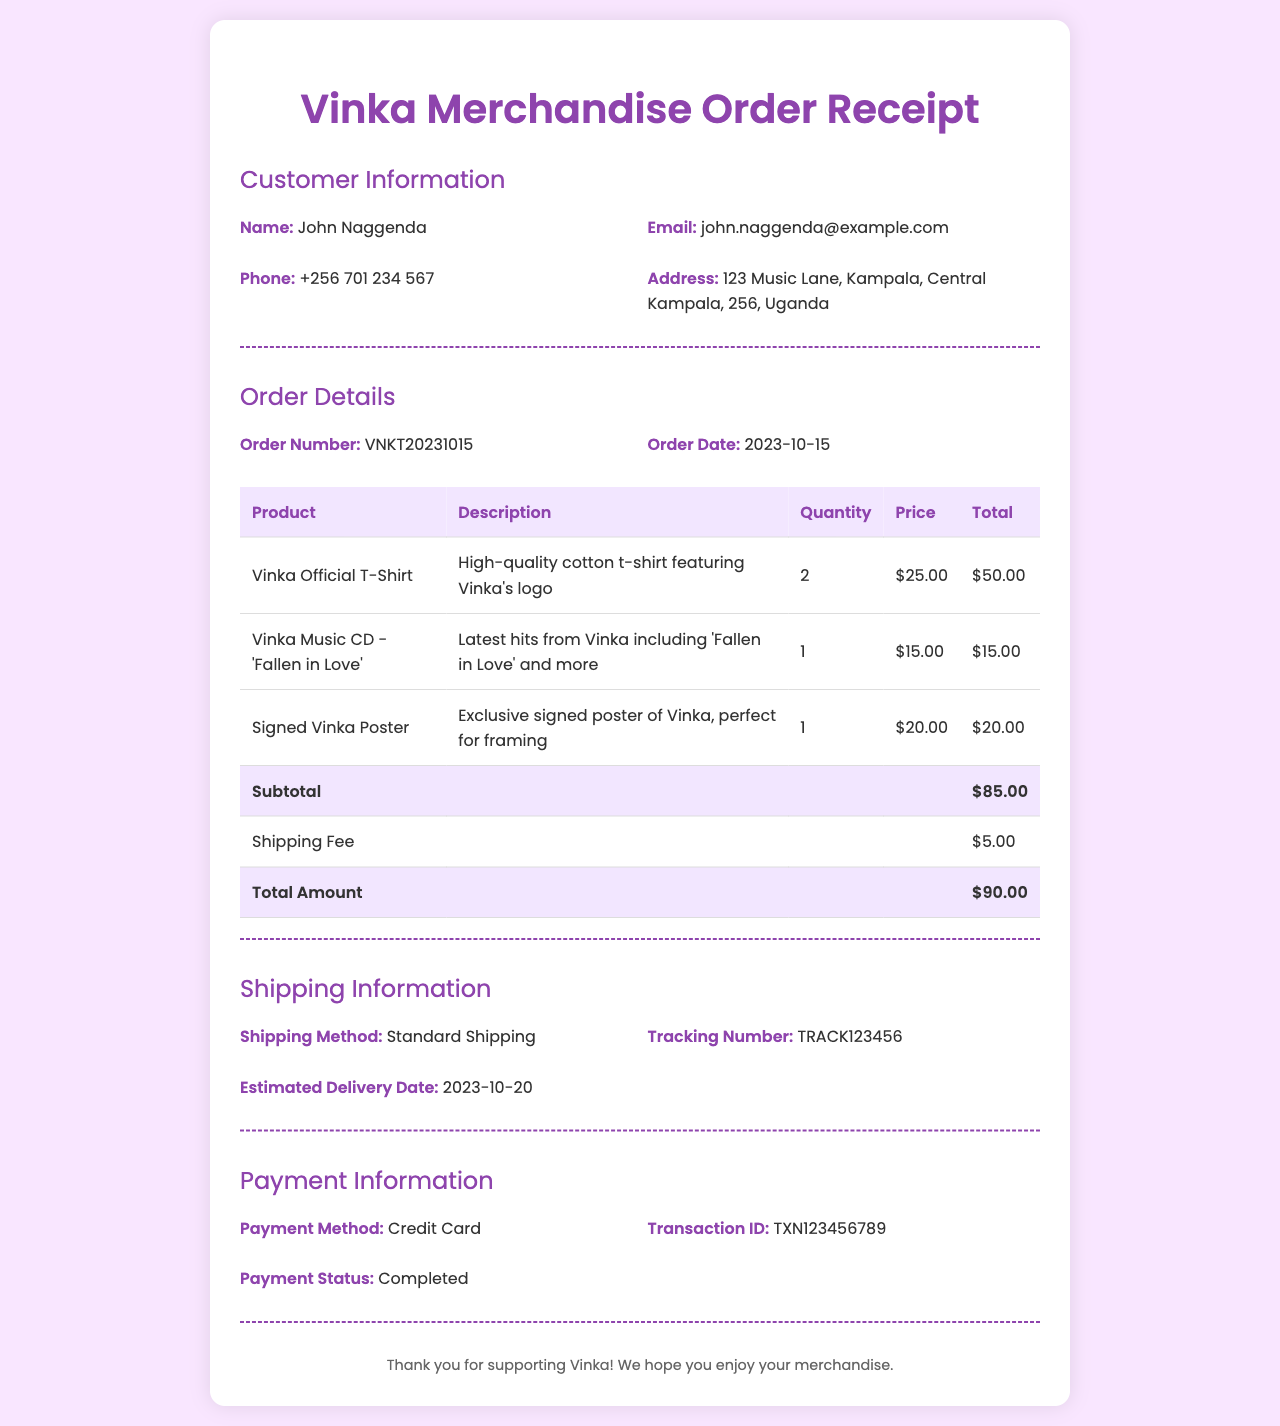What is the order number? The order number is found in the order details section of the document, specifically listed as VNKT20231015.
Answer: VNKT20231015 What is the total amount paid? The total amount is the final figure shown in the order details table, which sums the subtotal and shipping fee, amounting to $90.00.
Answer: $90.00 Who is the customer? The customer's name is provided in the customer information section, which clearly states John Naggenda as the name.
Answer: John Naggenda When is the estimated delivery date? The estimated delivery date is mentioned in the shipping information section, which states it is 2023-10-20.
Answer: 2023-10-20 What payment method was used? The payment method used is detailed in the payment information section, clearly indicating Credit Card as the method.
Answer: Credit Card How many Vinka Official T-Shirts were ordered? The quantity of Vinka Official T-Shirts can be found in the order details table, which shows 2 shirts were ordered.
Answer: 2 What is the shipping fee? The shipping fee is specified in the order details table, which indicates that it is $5.00.
Answer: $5.00 What is the transaction ID? The transaction ID is listed in the payment information section, which provides the ID as TXN123456789.
Answer: TXN123456789 What item is the signed poster? The signed poster is described in the order details table, identified as Signed Vinka Poster.
Answer: Signed Vinka Poster 